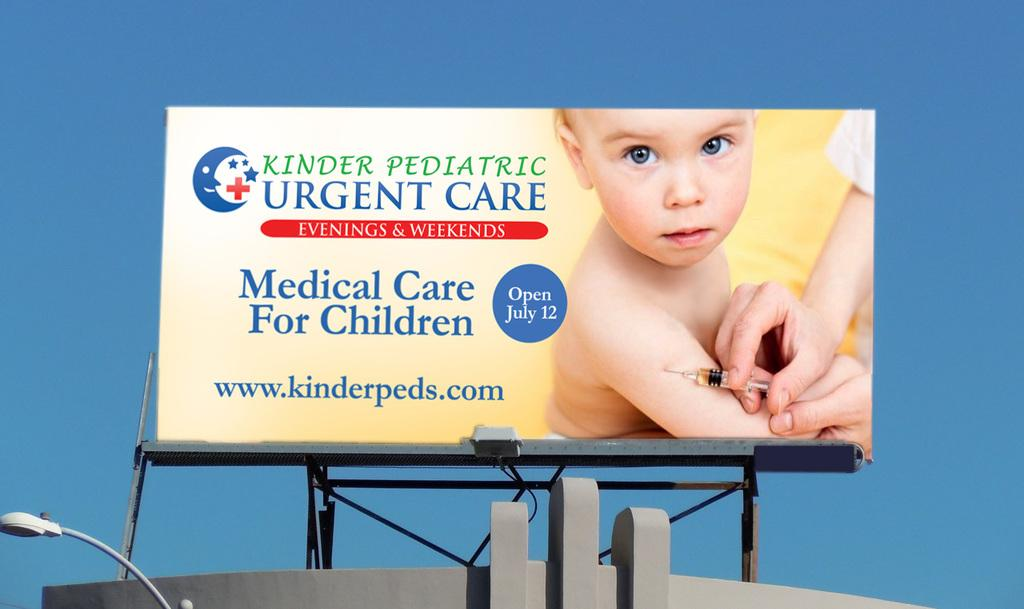<image>
Render a clear and concise summary of the photo. a billboard that says 'kinder pediatric urgent care' on it 